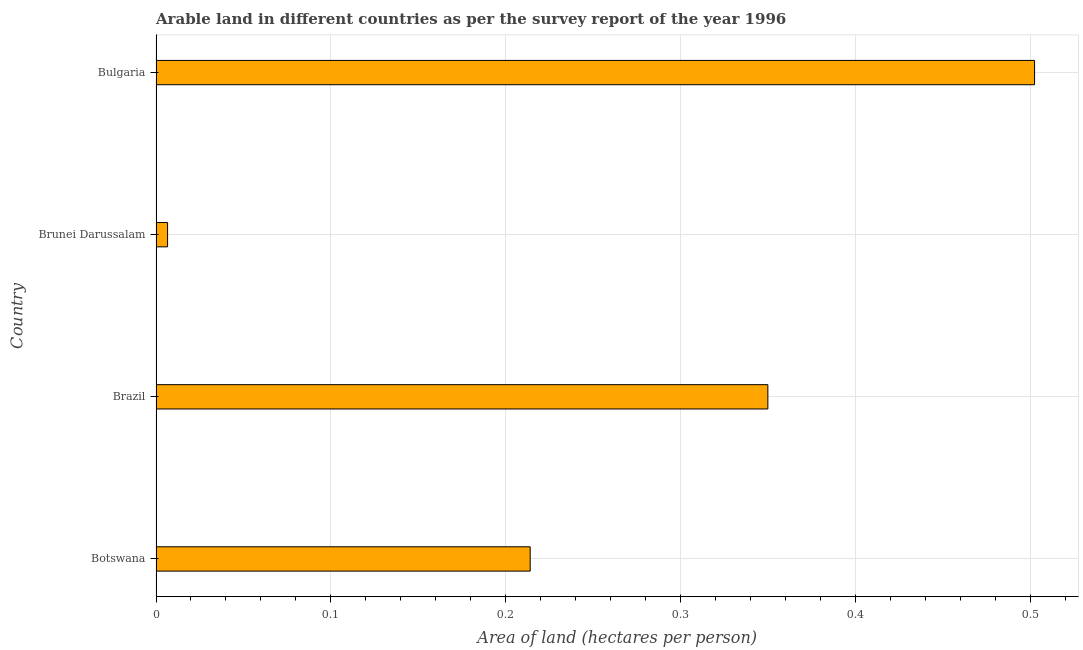Does the graph contain any zero values?
Offer a terse response. No. What is the title of the graph?
Make the answer very short. Arable land in different countries as per the survey report of the year 1996. What is the label or title of the X-axis?
Your answer should be compact. Area of land (hectares per person). What is the label or title of the Y-axis?
Your answer should be very brief. Country. What is the area of arable land in Bulgaria?
Provide a short and direct response. 0.5. Across all countries, what is the maximum area of arable land?
Make the answer very short. 0.5. Across all countries, what is the minimum area of arable land?
Keep it short and to the point. 0.01. In which country was the area of arable land minimum?
Give a very brief answer. Brunei Darussalam. What is the sum of the area of arable land?
Provide a succinct answer. 1.07. What is the difference between the area of arable land in Botswana and Brunei Darussalam?
Your answer should be compact. 0.21. What is the average area of arable land per country?
Provide a succinct answer. 0.27. What is the median area of arable land?
Offer a very short reply. 0.28. What is the ratio of the area of arable land in Brunei Darussalam to that in Bulgaria?
Your answer should be compact. 0.01. Is the area of arable land in Brazil less than that in Brunei Darussalam?
Your answer should be compact. No. What is the difference between the highest and the second highest area of arable land?
Provide a succinct answer. 0.15. What is the difference between the highest and the lowest area of arable land?
Give a very brief answer. 0.5. How many bars are there?
Offer a very short reply. 4. Are all the bars in the graph horizontal?
Provide a short and direct response. Yes. What is the difference between two consecutive major ticks on the X-axis?
Keep it short and to the point. 0.1. What is the Area of land (hectares per person) of Botswana?
Provide a succinct answer. 0.21. What is the Area of land (hectares per person) in Brazil?
Your response must be concise. 0.35. What is the Area of land (hectares per person) of Brunei Darussalam?
Offer a terse response. 0.01. What is the Area of land (hectares per person) in Bulgaria?
Give a very brief answer. 0.5. What is the difference between the Area of land (hectares per person) in Botswana and Brazil?
Your response must be concise. -0.14. What is the difference between the Area of land (hectares per person) in Botswana and Brunei Darussalam?
Offer a very short reply. 0.21. What is the difference between the Area of land (hectares per person) in Botswana and Bulgaria?
Your response must be concise. -0.29. What is the difference between the Area of land (hectares per person) in Brazil and Brunei Darussalam?
Offer a terse response. 0.34. What is the difference between the Area of land (hectares per person) in Brazil and Bulgaria?
Make the answer very short. -0.15. What is the difference between the Area of land (hectares per person) in Brunei Darussalam and Bulgaria?
Make the answer very short. -0.5. What is the ratio of the Area of land (hectares per person) in Botswana to that in Brazil?
Your response must be concise. 0.61. What is the ratio of the Area of land (hectares per person) in Botswana to that in Brunei Darussalam?
Provide a succinct answer. 32.37. What is the ratio of the Area of land (hectares per person) in Botswana to that in Bulgaria?
Your answer should be compact. 0.43. What is the ratio of the Area of land (hectares per person) in Brazil to that in Brunei Darussalam?
Your answer should be very brief. 52.93. What is the ratio of the Area of land (hectares per person) in Brazil to that in Bulgaria?
Offer a terse response. 0.7. What is the ratio of the Area of land (hectares per person) in Brunei Darussalam to that in Bulgaria?
Provide a short and direct response. 0.01. 